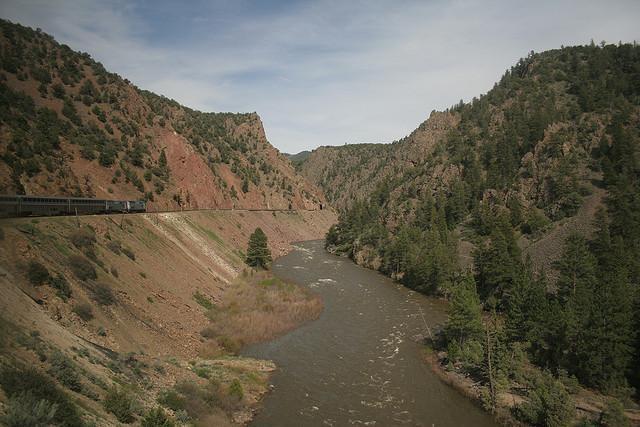How many zebras are eating grass in the image? there are zebras not eating grass too?
Give a very brief answer. 0. 